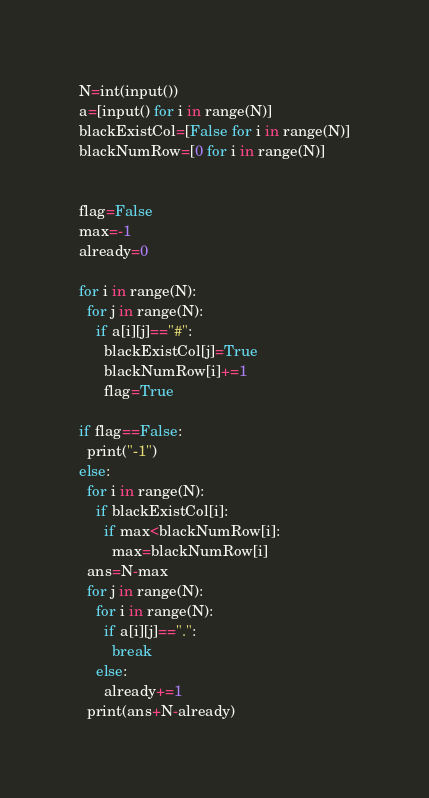<code> <loc_0><loc_0><loc_500><loc_500><_Python_>N=int(input())
a=[input() for i in range(N)]
blackExistCol=[False for i in range(N)]
blackNumRow=[0 for i in range(N)]


flag=False
max=-1
already=0

for i in range(N):
  for j in range(N):
    if a[i][j]=="#":
      blackExistCol[j]=True
      blackNumRow[i]+=1
      flag=True

if flag==False:
  print("-1")
else:
  for i in range(N):
    if blackExistCol[i]:
      if max<blackNumRow[i]:
        max=blackNumRow[i]
  ans=N-max
  for j in range(N):
    for i in range(N):
      if a[i][j]==".":
        break
    else:
      already+=1
  print(ans+N-already)</code> 